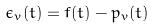Convert formula to latex. <formula><loc_0><loc_0><loc_500><loc_500>\epsilon _ { v } ( t ) = f ( t ) - p _ { v } ( t )</formula> 